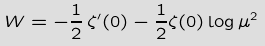<formula> <loc_0><loc_0><loc_500><loc_500>W = - \frac { 1 } { 2 } \, \zeta ^ { \prime } ( 0 ) - \frac { 1 } { 2 } \zeta ( 0 ) \log \mu ^ { 2 }</formula> 